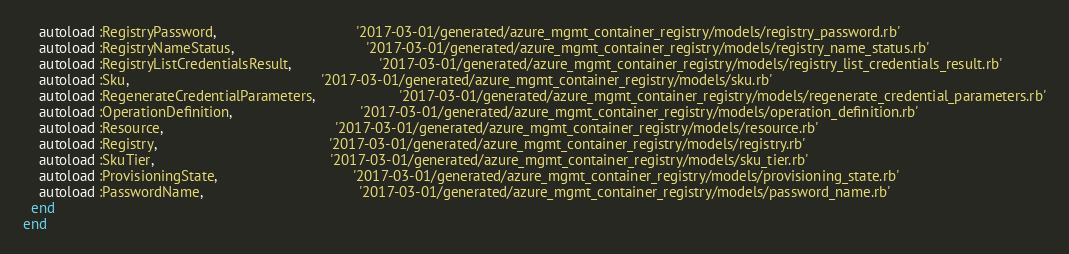<code> <loc_0><loc_0><loc_500><loc_500><_Ruby_>    autoload :RegistryPassword,                                   '2017-03-01/generated/azure_mgmt_container_registry/models/registry_password.rb'
    autoload :RegistryNameStatus,                                 '2017-03-01/generated/azure_mgmt_container_registry/models/registry_name_status.rb'
    autoload :RegistryListCredentialsResult,                      '2017-03-01/generated/azure_mgmt_container_registry/models/registry_list_credentials_result.rb'
    autoload :Sku,                                                '2017-03-01/generated/azure_mgmt_container_registry/models/sku.rb'
    autoload :RegenerateCredentialParameters,                     '2017-03-01/generated/azure_mgmt_container_registry/models/regenerate_credential_parameters.rb'
    autoload :OperationDefinition,                                '2017-03-01/generated/azure_mgmt_container_registry/models/operation_definition.rb'
    autoload :Resource,                                           '2017-03-01/generated/azure_mgmt_container_registry/models/resource.rb'
    autoload :Registry,                                           '2017-03-01/generated/azure_mgmt_container_registry/models/registry.rb'
    autoload :SkuTier,                                            '2017-03-01/generated/azure_mgmt_container_registry/models/sku_tier.rb'
    autoload :ProvisioningState,                                  '2017-03-01/generated/azure_mgmt_container_registry/models/provisioning_state.rb'
    autoload :PasswordName,                                       '2017-03-01/generated/azure_mgmt_container_registry/models/password_name.rb'
  end
end
</code> 